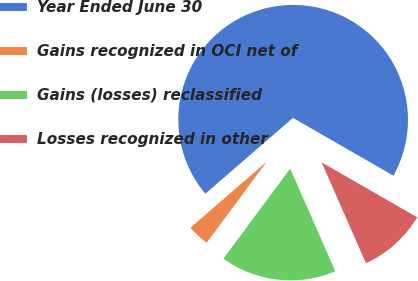Convert chart to OTSL. <chart><loc_0><loc_0><loc_500><loc_500><pie_chart><fcel>Year Ended June 30<fcel>Gains recognized in OCI net of<fcel>Gains (losses) reclassified<fcel>Losses recognized in other<nl><fcel>69.66%<fcel>3.5%<fcel>16.73%<fcel>10.11%<nl></chart> 